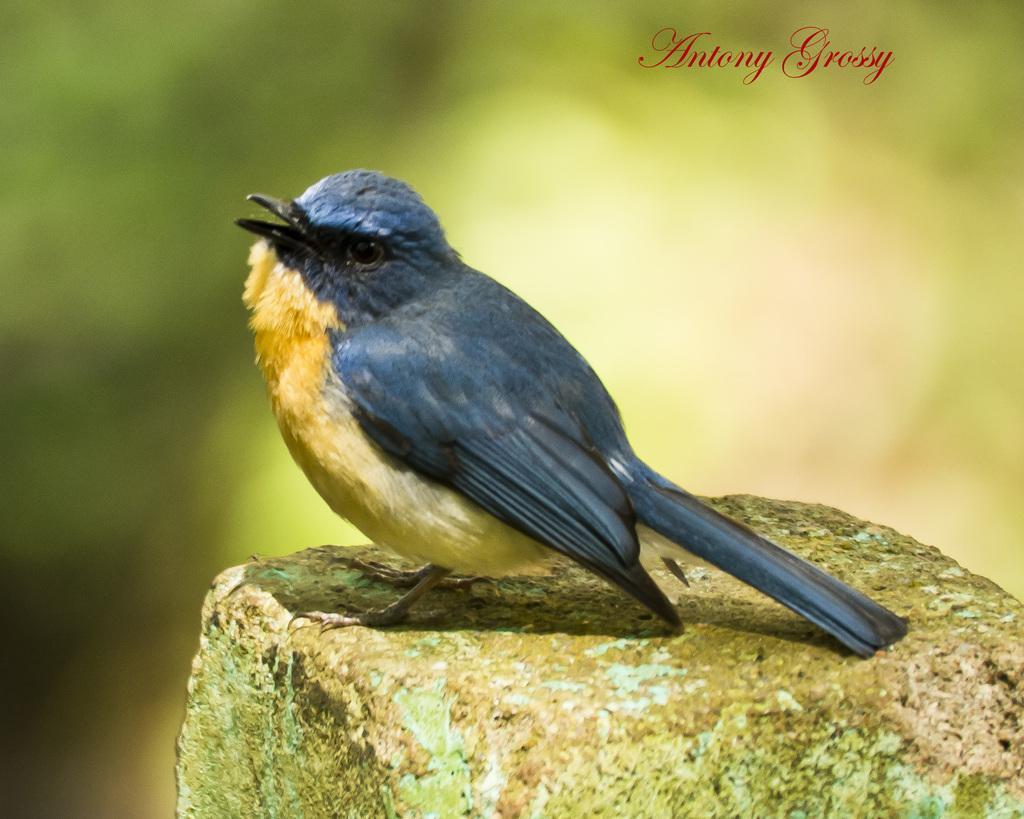How would you summarize this image in a sentence or two? In this image I see a bird which is of blue and yellow in color and it is on this stone and I see the watermark over here and I see that it is blurred in the background. 